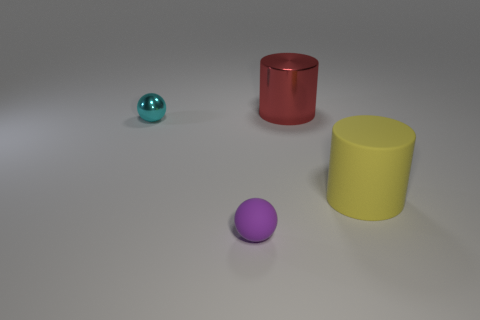What can you say about the lighting and shadows in the image? The lighting in the image is diffused, causing soft shadows that extend towards the right from each object. The even lighting suggests an indirect light source, likely positioned above the scene, providing a clear view of the objects without any harsh reflections. 